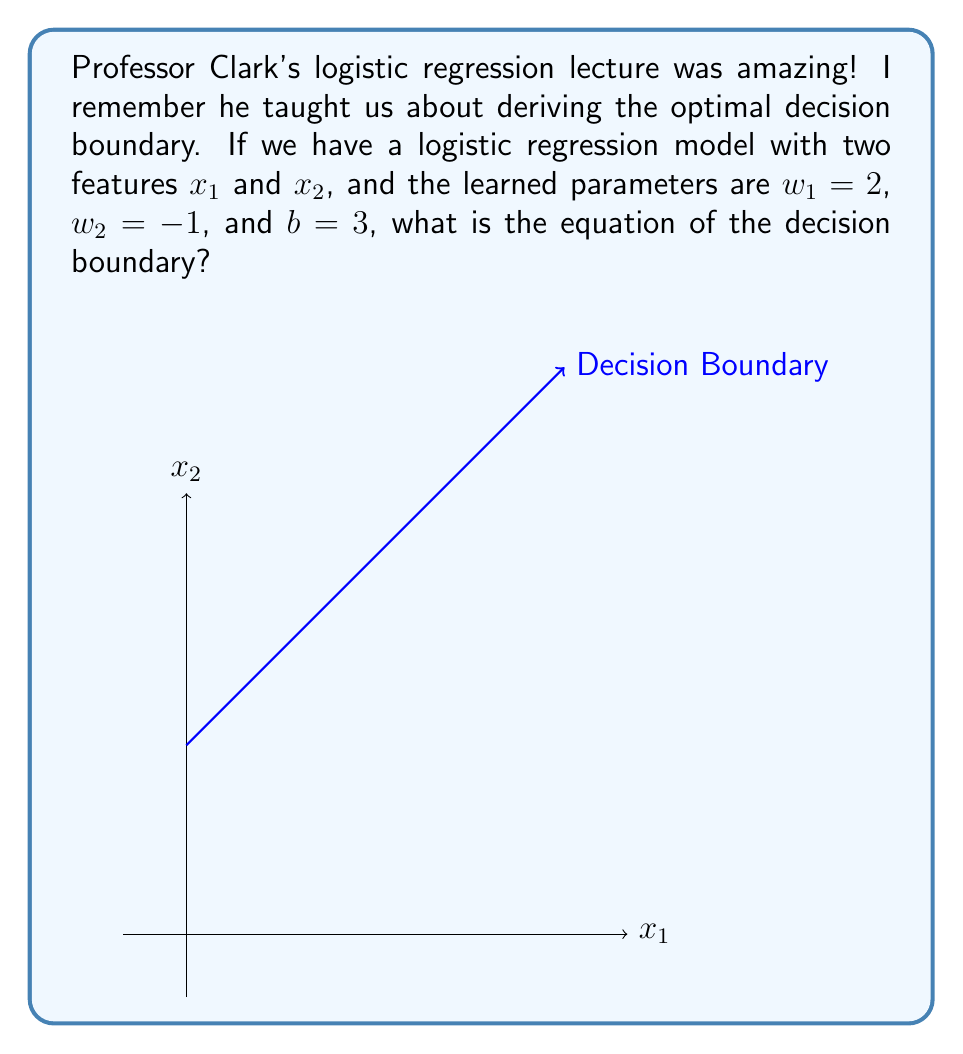Give your solution to this math problem. Let's approach this step-by-step:

1) In logistic regression, the probability of the positive class is given by the sigmoid function:

   $$P(y=1|x) = \frac{1}{1 + e^{-(w^T x + b)}}$$

2) The decision boundary is where the probability equals 0.5:

   $$P(y=1|x) = 0.5$$

3) This occurs when the exponent of e is zero:

   $$w^T x + b = 0$$

4) In our case, with two features, this expands to:

   $$w_1x_1 + w_2x_2 + b = 0$$

5) We're given $w_1 = 2$, $w_2 = -1$, and $b = 3$. Let's substitute these values:

   $$2x_1 + (-1)x_2 + 3 = 0$$

6) Simplify:

   $$2x_1 - x_2 + 3 = 0$$

7) Rearrange to standard form of a line $y = mx + c$:

   $$x_2 = 2x_1 + 3$$

This equation represents the decision boundary in the $x_1$-$x_2$ plane.
Answer: $x_2 = 2x_1 + 3$ 